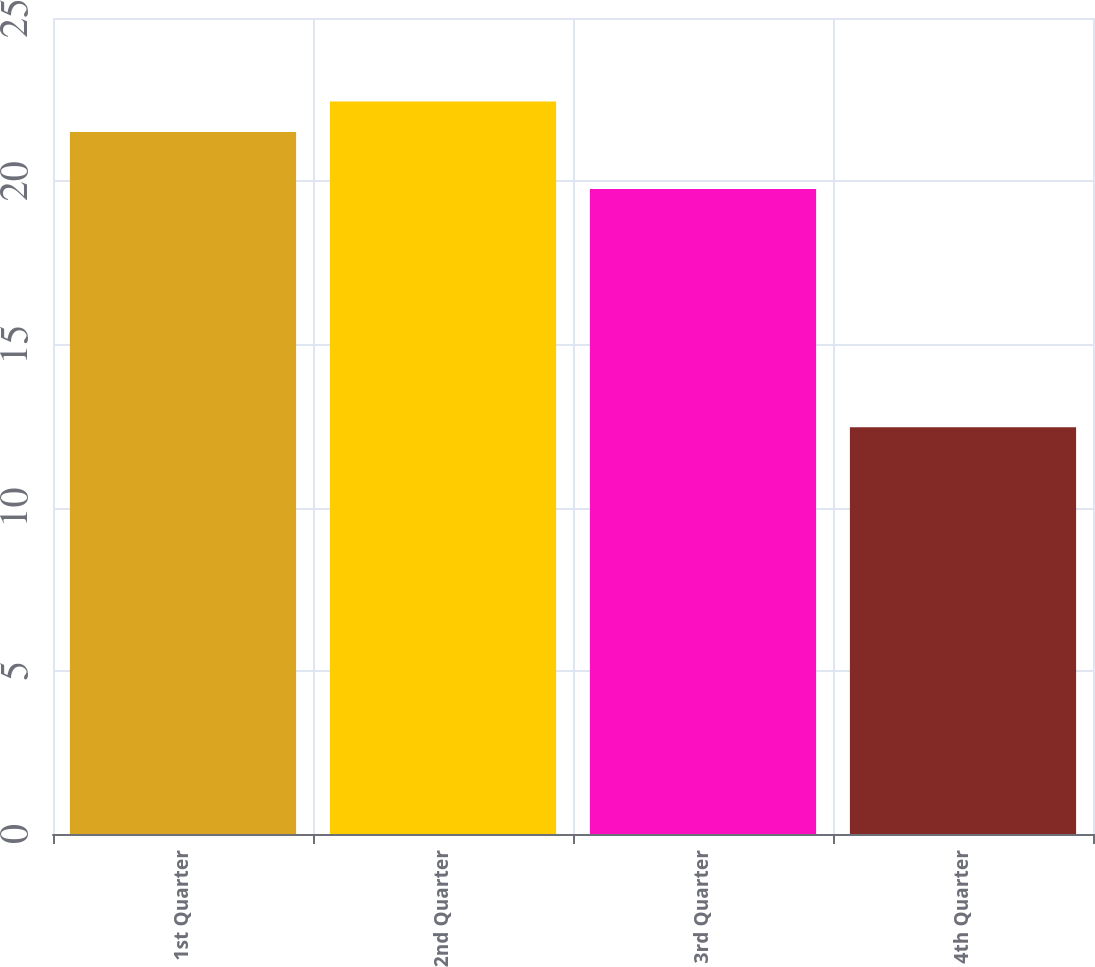Convert chart to OTSL. <chart><loc_0><loc_0><loc_500><loc_500><bar_chart><fcel>1st Quarter<fcel>2nd Quarter<fcel>3rd Quarter<fcel>4th Quarter<nl><fcel>21.51<fcel>22.44<fcel>19.76<fcel>12.46<nl></chart> 